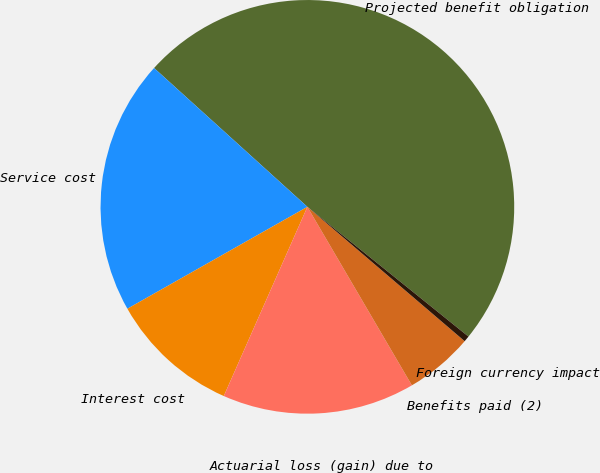<chart> <loc_0><loc_0><loc_500><loc_500><pie_chart><fcel>Projected benefit obligation<fcel>Service cost<fcel>Interest cost<fcel>Actuarial loss (gain) due to<fcel>Benefits paid (2)<fcel>Foreign currency impact<nl><fcel>49.08%<fcel>19.91%<fcel>10.18%<fcel>15.05%<fcel>5.32%<fcel>0.46%<nl></chart> 